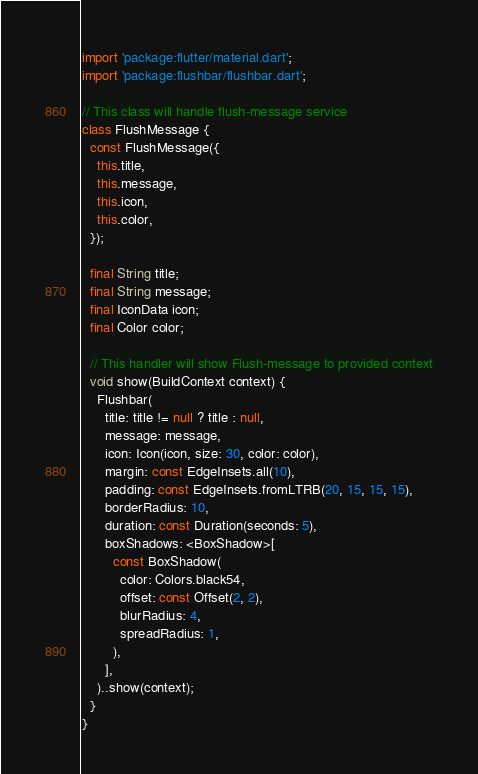<code> <loc_0><loc_0><loc_500><loc_500><_Dart_>import 'package:flutter/material.dart';
import 'package:flushbar/flushbar.dart';

// This class will handle flush-message service
class FlushMessage {
  const FlushMessage({
    this.title,
    this.message,
    this.icon,
    this.color,
  });

  final String title;
  final String message;
  final IconData icon;
  final Color color;

  // This handler will show Flush-message to provided context
  void show(BuildContext context) {
    Flushbar(
      title: title != null ? title : null,
      message: message,
      icon: Icon(icon, size: 30, color: color),
      margin: const EdgeInsets.all(10),
      padding: const EdgeInsets.fromLTRB(20, 15, 15, 15),
      borderRadius: 10,
      duration: const Duration(seconds: 5),
      boxShadows: <BoxShadow>[
        const BoxShadow(
          color: Colors.black54,
          offset: const Offset(2, 2),
          blurRadius: 4,
          spreadRadius: 1,
        ),
      ],
    )..show(context);
  }
}
</code> 